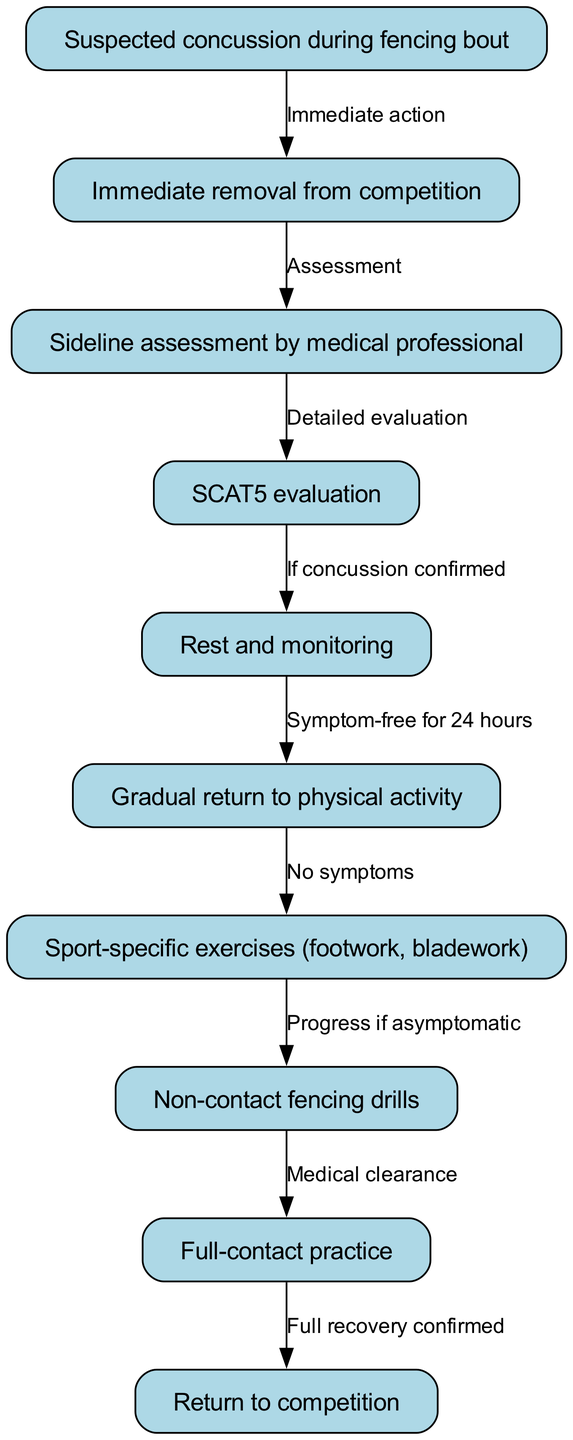What is the first action taken when a concussion is suspected? The diagram shows that the first action is the "Immediate removal from competition" after a concussion is suspected. This action is graphically represented as the initial step in the pathway.
Answer: Immediate removal from competition How many steps are there in the return-to-play process? By counting the nodes that represent the gradual return to physical activity, we can see there are several steps leading back to competition, specifically nodes 6 through 10. Therefore, there are five steps in total after the initial recovery stage.
Answer: Five steps What evaluation is performed after the sideline assessment? The diagram indicates that after the sideline assessment by a medical professional, a "SCAT5 evaluation" follows as a detailed evaluation of the suspected concussion. This is indicated directly from the relevant node.
Answer: SCAT5 evaluation What indicates that a fencer can progress from rest to physical activity? The documentation states that the fencer can transition from "Rest and monitoring" to "Gradual return to physical activity" only if they are "Symptom-free for 24 hours." This connection in the flow of the diagram outlines the prerequisites for progression.
Answer: Symptom-free for 24 hours What is necessary before a fencer can engage in full-contact practice? The diagram specifies that before moving on to "Full-contact practice," the fencer must receive "Medical clearance" following non-contact fencing drills. This step ensures the athlete is safe to increase intensity before returning to full-scale competition.
Answer: Medical clearance 